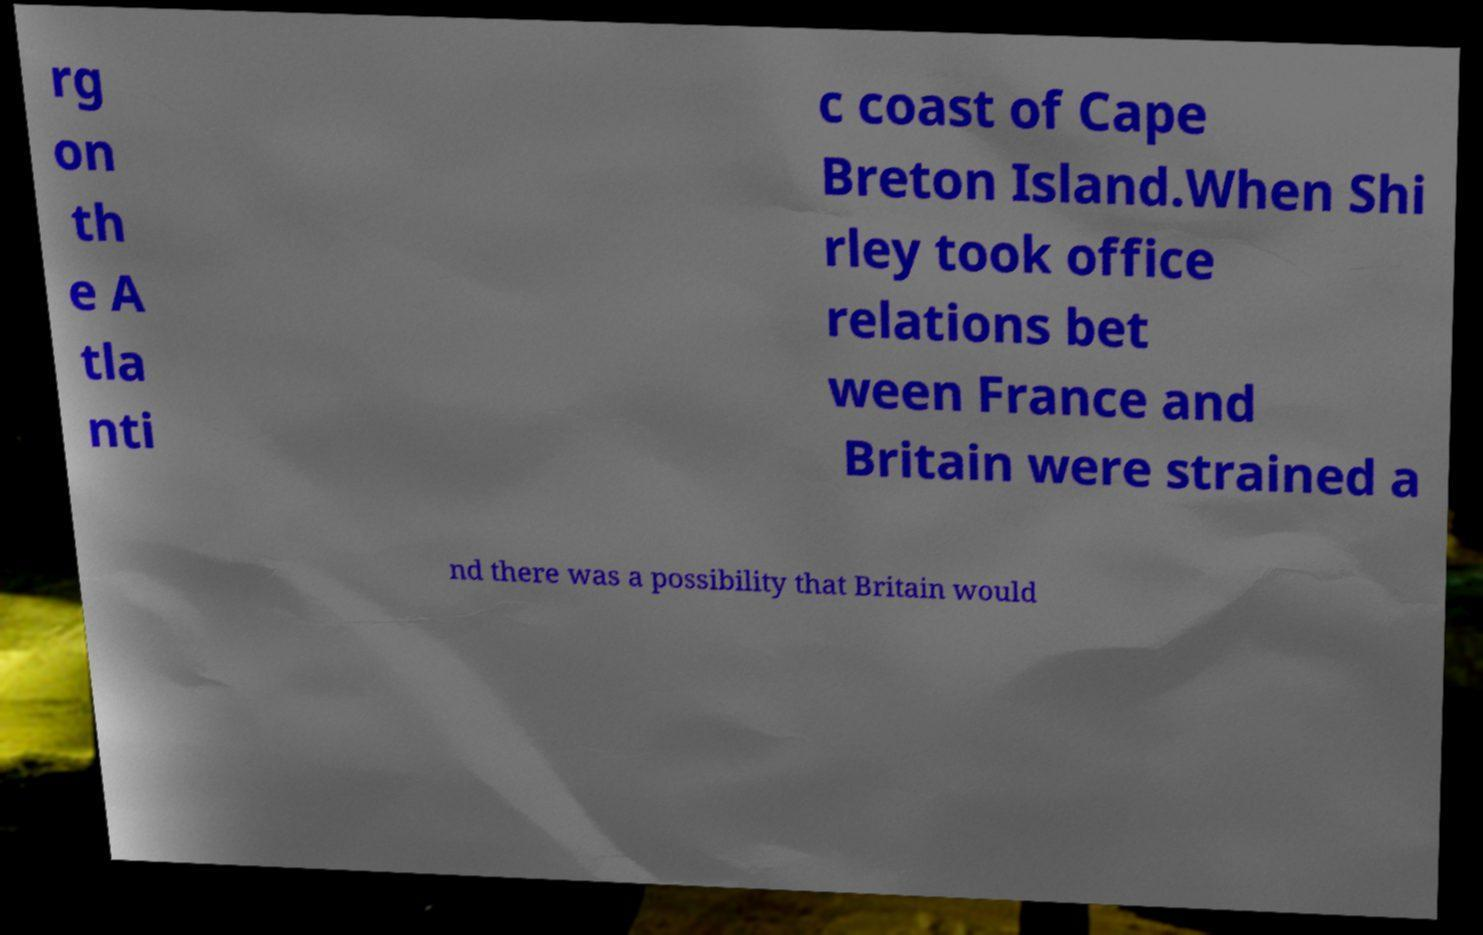I need the written content from this picture converted into text. Can you do that? rg on th e A tla nti c coast of Cape Breton Island.When Shi rley took office relations bet ween France and Britain were strained a nd there was a possibility that Britain would 